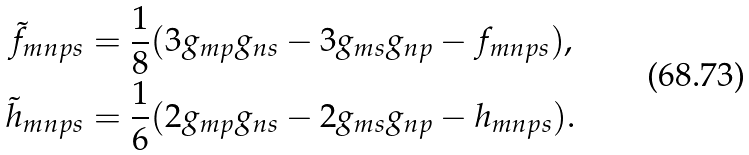<formula> <loc_0><loc_0><loc_500><loc_500>\tilde { f } _ { m n p s } & = \frac { 1 } { 8 } ( 3 g _ { m p } g _ { n s } - 3 g _ { m s } g _ { n p } - f _ { m n p s } ) , \\ \tilde { h } _ { m n p s } & = \frac { 1 } { 6 } ( 2 g _ { m p } g _ { n s } - 2 g _ { m s } g _ { n p } - h _ { m n p s } ) .</formula> 